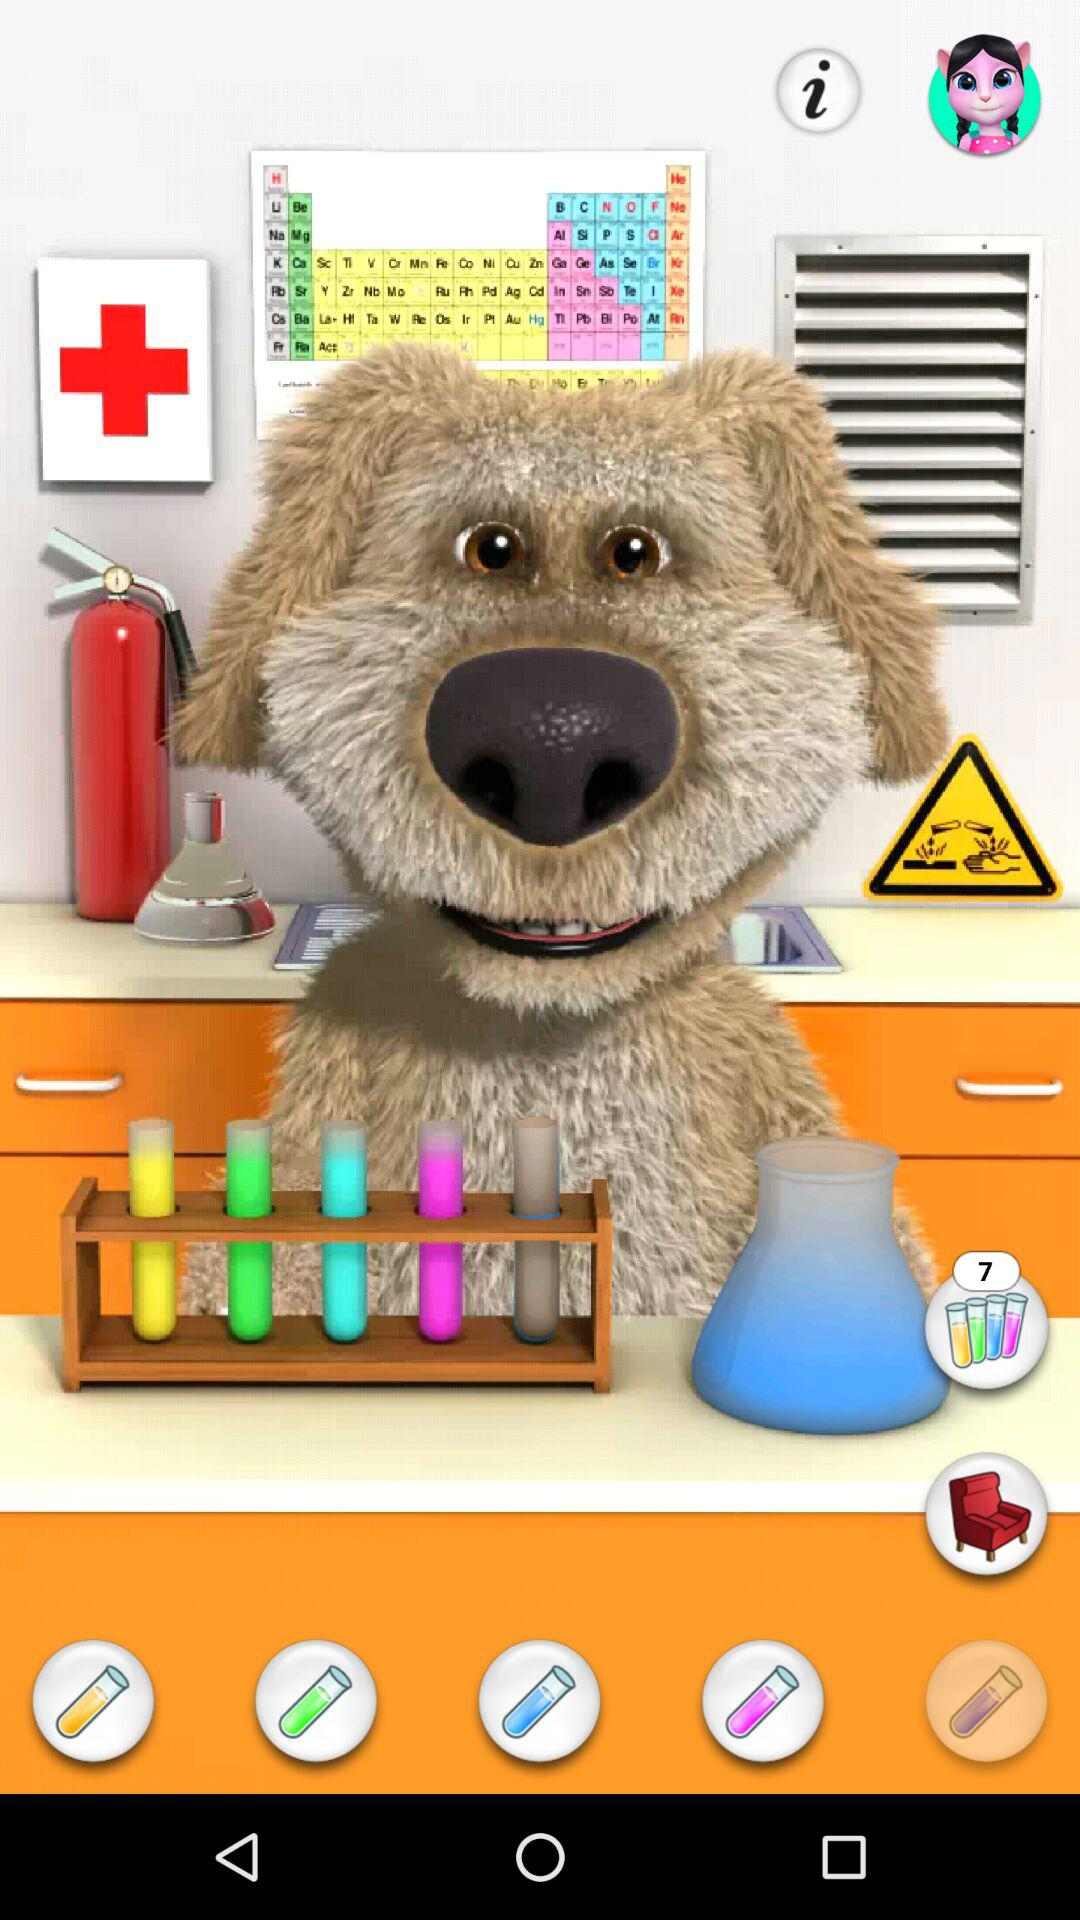How many test tubes have a blue liquid in them?
Answer the question using a single word or phrase. 3 